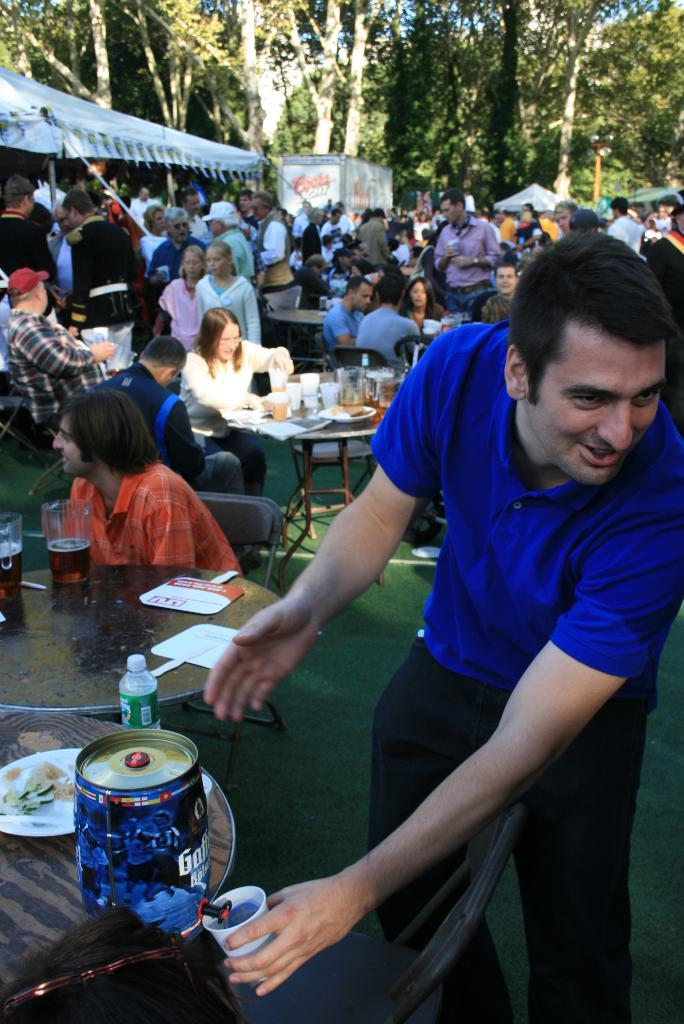Who is present in the image? There is a man in the image. What is the man doing in the image? The man is standing and smiling. What is in front of the man in the image? There is a table in front of the man. What can be seen in the background of the image? There is a crowd of people and trees visible in the background of the image. What type of attraction is the man riding in the image? There is no attraction present in the image; the man is standing next to a table. Can you tell me how many yaks are visible in the image? There are no yaks present in the image. 